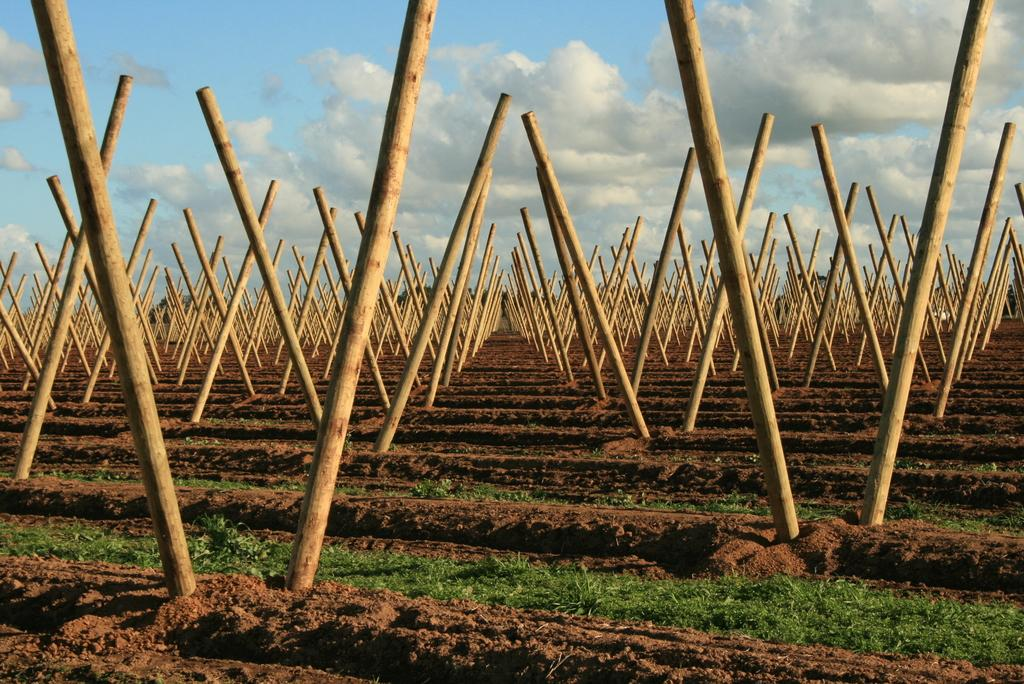What type of objects can be seen in the image? There are wooden poles in the image. What is the ground made of in the image? The ground contains soil and grass. What can be seen in the background of the image? There is sky visible in the background of the image. What is present in the sky in the image? Clouds are present in the sky. How many girls are holding a drink while standing near the wooden poles in the image? There are no girls or drinks present in the image; it only features wooden poles, soil, grass, sky, and clouds. 